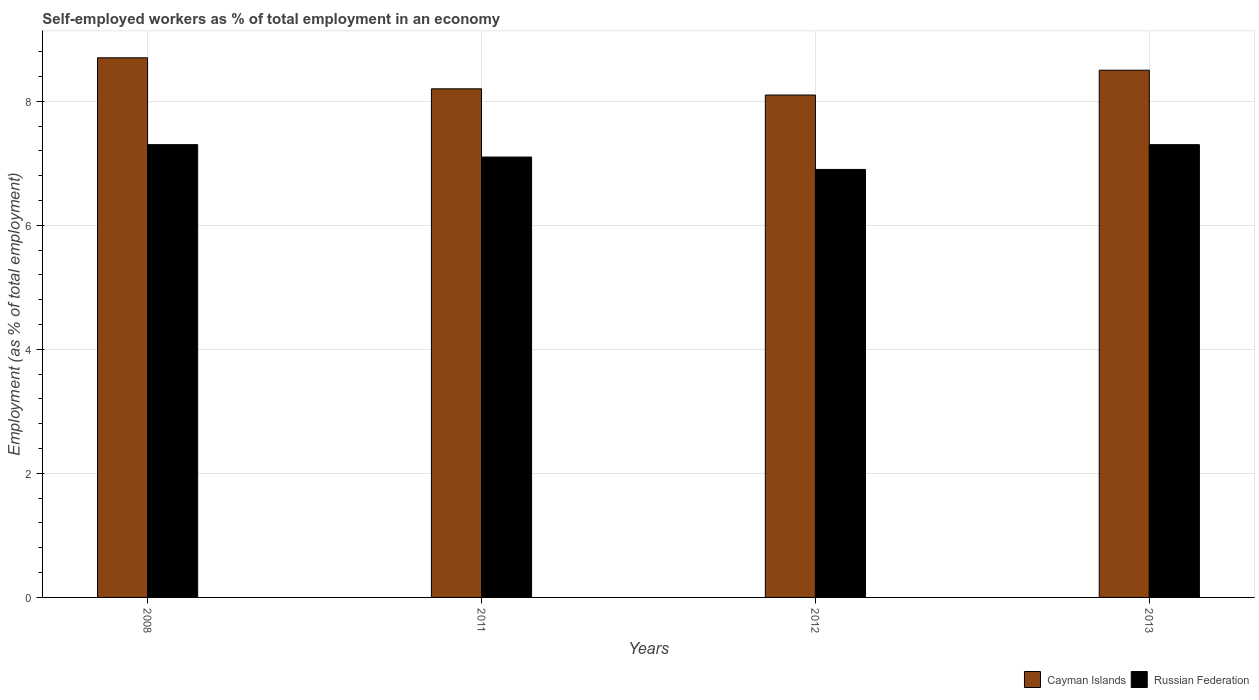How many different coloured bars are there?
Provide a succinct answer. 2. How many groups of bars are there?
Your answer should be compact. 4. How many bars are there on the 3rd tick from the right?
Your answer should be very brief. 2. In how many cases, is the number of bars for a given year not equal to the number of legend labels?
Provide a short and direct response. 0. What is the percentage of self-employed workers in Cayman Islands in 2012?
Ensure brevity in your answer.  8.1. Across all years, what is the maximum percentage of self-employed workers in Cayman Islands?
Provide a short and direct response. 8.7. Across all years, what is the minimum percentage of self-employed workers in Cayman Islands?
Offer a terse response. 8.1. What is the total percentage of self-employed workers in Cayman Islands in the graph?
Offer a very short reply. 33.5. What is the difference between the percentage of self-employed workers in Russian Federation in 2008 and that in 2011?
Ensure brevity in your answer.  0.2. What is the difference between the percentage of self-employed workers in Cayman Islands in 2011 and the percentage of self-employed workers in Russian Federation in 2008?
Make the answer very short. 0.9. What is the average percentage of self-employed workers in Russian Federation per year?
Make the answer very short. 7.15. In the year 2012, what is the difference between the percentage of self-employed workers in Cayman Islands and percentage of self-employed workers in Russian Federation?
Provide a short and direct response. 1.2. In how many years, is the percentage of self-employed workers in Cayman Islands greater than 4 %?
Provide a short and direct response. 4. What is the ratio of the percentage of self-employed workers in Russian Federation in 2011 to that in 2012?
Ensure brevity in your answer.  1.03. What is the difference between the highest and the second highest percentage of self-employed workers in Cayman Islands?
Provide a short and direct response. 0.2. What is the difference between the highest and the lowest percentage of self-employed workers in Russian Federation?
Keep it short and to the point. 0.4. What does the 1st bar from the left in 2013 represents?
Provide a succinct answer. Cayman Islands. What does the 1st bar from the right in 2011 represents?
Provide a short and direct response. Russian Federation. What is the difference between two consecutive major ticks on the Y-axis?
Your response must be concise. 2. Does the graph contain any zero values?
Make the answer very short. No. Where does the legend appear in the graph?
Provide a succinct answer. Bottom right. How many legend labels are there?
Keep it short and to the point. 2. How are the legend labels stacked?
Give a very brief answer. Horizontal. What is the title of the graph?
Ensure brevity in your answer.  Self-employed workers as % of total employment in an economy. What is the label or title of the X-axis?
Provide a succinct answer. Years. What is the label or title of the Y-axis?
Offer a terse response. Employment (as % of total employment). What is the Employment (as % of total employment) in Cayman Islands in 2008?
Your answer should be compact. 8.7. What is the Employment (as % of total employment) of Russian Federation in 2008?
Provide a short and direct response. 7.3. What is the Employment (as % of total employment) of Cayman Islands in 2011?
Keep it short and to the point. 8.2. What is the Employment (as % of total employment) of Russian Federation in 2011?
Make the answer very short. 7.1. What is the Employment (as % of total employment) in Cayman Islands in 2012?
Your response must be concise. 8.1. What is the Employment (as % of total employment) of Russian Federation in 2012?
Provide a succinct answer. 6.9. What is the Employment (as % of total employment) of Cayman Islands in 2013?
Keep it short and to the point. 8.5. What is the Employment (as % of total employment) in Russian Federation in 2013?
Your response must be concise. 7.3. Across all years, what is the maximum Employment (as % of total employment) of Cayman Islands?
Your answer should be very brief. 8.7. Across all years, what is the maximum Employment (as % of total employment) in Russian Federation?
Your response must be concise. 7.3. Across all years, what is the minimum Employment (as % of total employment) of Cayman Islands?
Your response must be concise. 8.1. Across all years, what is the minimum Employment (as % of total employment) of Russian Federation?
Your answer should be compact. 6.9. What is the total Employment (as % of total employment) in Cayman Islands in the graph?
Provide a short and direct response. 33.5. What is the total Employment (as % of total employment) of Russian Federation in the graph?
Offer a very short reply. 28.6. What is the difference between the Employment (as % of total employment) of Cayman Islands in 2008 and that in 2011?
Provide a short and direct response. 0.5. What is the difference between the Employment (as % of total employment) of Cayman Islands in 2008 and that in 2012?
Offer a very short reply. 0.6. What is the difference between the Employment (as % of total employment) of Russian Federation in 2008 and that in 2012?
Offer a very short reply. 0.4. What is the difference between the Employment (as % of total employment) in Russian Federation in 2008 and that in 2013?
Give a very brief answer. 0. What is the difference between the Employment (as % of total employment) of Cayman Islands in 2008 and the Employment (as % of total employment) of Russian Federation in 2013?
Make the answer very short. 1.4. What is the difference between the Employment (as % of total employment) of Cayman Islands in 2012 and the Employment (as % of total employment) of Russian Federation in 2013?
Ensure brevity in your answer.  0.8. What is the average Employment (as % of total employment) of Cayman Islands per year?
Offer a very short reply. 8.38. What is the average Employment (as % of total employment) of Russian Federation per year?
Your response must be concise. 7.15. In the year 2012, what is the difference between the Employment (as % of total employment) of Cayman Islands and Employment (as % of total employment) of Russian Federation?
Your response must be concise. 1.2. What is the ratio of the Employment (as % of total employment) of Cayman Islands in 2008 to that in 2011?
Make the answer very short. 1.06. What is the ratio of the Employment (as % of total employment) in Russian Federation in 2008 to that in 2011?
Your answer should be very brief. 1.03. What is the ratio of the Employment (as % of total employment) of Cayman Islands in 2008 to that in 2012?
Provide a succinct answer. 1.07. What is the ratio of the Employment (as % of total employment) in Russian Federation in 2008 to that in 2012?
Your response must be concise. 1.06. What is the ratio of the Employment (as % of total employment) in Cayman Islands in 2008 to that in 2013?
Your answer should be compact. 1.02. What is the ratio of the Employment (as % of total employment) of Cayman Islands in 2011 to that in 2012?
Ensure brevity in your answer.  1.01. What is the ratio of the Employment (as % of total employment) in Russian Federation in 2011 to that in 2012?
Your answer should be compact. 1.03. What is the ratio of the Employment (as % of total employment) of Cayman Islands in 2011 to that in 2013?
Give a very brief answer. 0.96. What is the ratio of the Employment (as % of total employment) in Russian Federation in 2011 to that in 2013?
Provide a short and direct response. 0.97. What is the ratio of the Employment (as % of total employment) of Cayman Islands in 2012 to that in 2013?
Your answer should be compact. 0.95. What is the ratio of the Employment (as % of total employment) of Russian Federation in 2012 to that in 2013?
Offer a terse response. 0.95. What is the difference between the highest and the second highest Employment (as % of total employment) of Cayman Islands?
Make the answer very short. 0.2. 